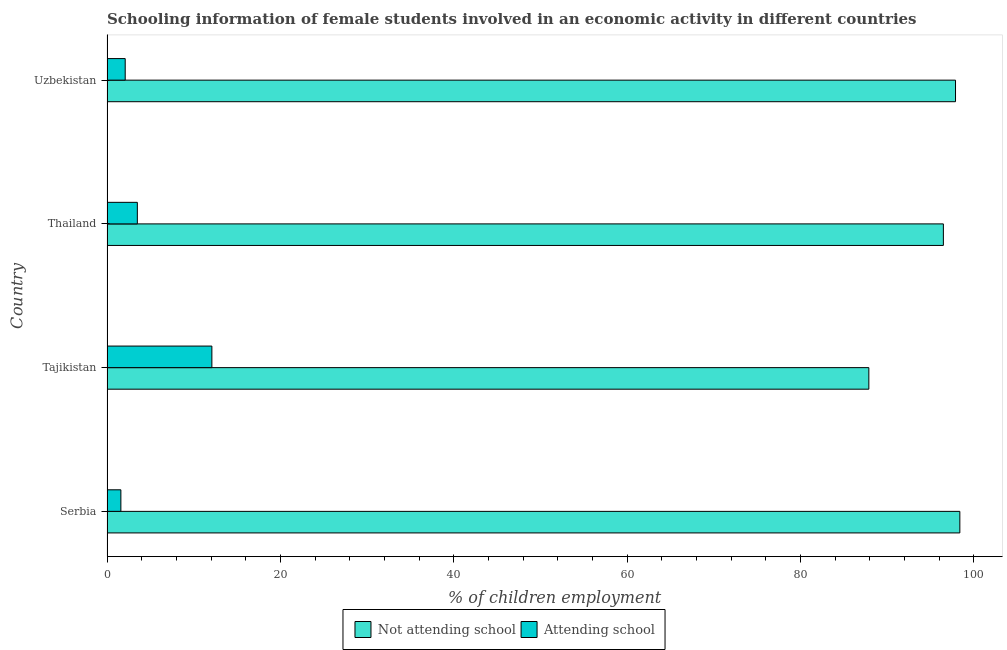How many groups of bars are there?
Give a very brief answer. 4. Are the number of bars on each tick of the Y-axis equal?
Offer a very short reply. Yes. How many bars are there on the 1st tick from the top?
Keep it short and to the point. 2. How many bars are there on the 3rd tick from the bottom?
Give a very brief answer. 2. What is the label of the 3rd group of bars from the top?
Provide a short and direct response. Tajikistan. In which country was the percentage of employed females who are not attending school maximum?
Provide a short and direct response. Serbia. In which country was the percentage of employed females who are not attending school minimum?
Provide a succinct answer. Tajikistan. What is the total percentage of employed females who are attending school in the graph?
Your response must be concise. 19.3. What is the difference between the percentage of employed females who are not attending school in Serbia and that in Uzbekistan?
Ensure brevity in your answer.  0.5. What is the difference between the percentage of employed females who are attending school in Uzbekistan and the percentage of employed females who are not attending school in Tajikistan?
Provide a short and direct response. -85.8. What is the average percentage of employed females who are not attending school per country?
Offer a very short reply. 95.17. What is the difference between the percentage of employed females who are not attending school and percentage of employed females who are attending school in Uzbekistan?
Offer a terse response. 95.8. What is the ratio of the percentage of employed females who are not attending school in Tajikistan to that in Uzbekistan?
Offer a terse response. 0.9. What is the difference between the highest and the second highest percentage of employed females who are attending school?
Keep it short and to the point. 8.6. Is the sum of the percentage of employed females who are not attending school in Serbia and Thailand greater than the maximum percentage of employed females who are attending school across all countries?
Provide a short and direct response. Yes. What does the 1st bar from the top in Uzbekistan represents?
Give a very brief answer. Attending school. What does the 2nd bar from the bottom in Thailand represents?
Your answer should be compact. Attending school. Are all the bars in the graph horizontal?
Ensure brevity in your answer.  Yes. Does the graph contain any zero values?
Offer a very short reply. No. Does the graph contain grids?
Offer a terse response. No. Where does the legend appear in the graph?
Your response must be concise. Bottom center. How many legend labels are there?
Offer a terse response. 2. What is the title of the graph?
Ensure brevity in your answer.  Schooling information of female students involved in an economic activity in different countries. What is the label or title of the X-axis?
Provide a succinct answer. % of children employment. What is the % of children employment of Not attending school in Serbia?
Provide a succinct answer. 98.4. What is the % of children employment of Not attending school in Tajikistan?
Make the answer very short. 87.9. What is the % of children employment in Attending school in Tajikistan?
Offer a terse response. 12.1. What is the % of children employment of Not attending school in Thailand?
Your answer should be compact. 96.5. What is the % of children employment in Attending school in Thailand?
Provide a short and direct response. 3.5. What is the % of children employment of Not attending school in Uzbekistan?
Give a very brief answer. 97.9. Across all countries, what is the maximum % of children employment of Not attending school?
Your answer should be compact. 98.4. Across all countries, what is the minimum % of children employment of Not attending school?
Give a very brief answer. 87.9. What is the total % of children employment of Not attending school in the graph?
Provide a short and direct response. 380.7. What is the total % of children employment of Attending school in the graph?
Your answer should be compact. 19.3. What is the difference between the % of children employment in Not attending school in Serbia and that in Tajikistan?
Make the answer very short. 10.5. What is the difference between the % of children employment of Attending school in Serbia and that in Thailand?
Your answer should be very brief. -1.9. What is the difference between the % of children employment in Attending school in Serbia and that in Uzbekistan?
Offer a terse response. -0.5. What is the difference between the % of children employment in Not attending school in Tajikistan and that in Thailand?
Your answer should be compact. -8.6. What is the difference between the % of children employment of Attending school in Tajikistan and that in Uzbekistan?
Offer a very short reply. 10. What is the difference between the % of children employment of Not attending school in Thailand and that in Uzbekistan?
Provide a short and direct response. -1.4. What is the difference between the % of children employment of Attending school in Thailand and that in Uzbekistan?
Provide a short and direct response. 1.4. What is the difference between the % of children employment of Not attending school in Serbia and the % of children employment of Attending school in Tajikistan?
Give a very brief answer. 86.3. What is the difference between the % of children employment in Not attending school in Serbia and the % of children employment in Attending school in Thailand?
Provide a succinct answer. 94.9. What is the difference between the % of children employment of Not attending school in Serbia and the % of children employment of Attending school in Uzbekistan?
Keep it short and to the point. 96.3. What is the difference between the % of children employment in Not attending school in Tajikistan and the % of children employment in Attending school in Thailand?
Offer a very short reply. 84.4. What is the difference between the % of children employment of Not attending school in Tajikistan and the % of children employment of Attending school in Uzbekistan?
Provide a succinct answer. 85.8. What is the difference between the % of children employment of Not attending school in Thailand and the % of children employment of Attending school in Uzbekistan?
Your answer should be compact. 94.4. What is the average % of children employment in Not attending school per country?
Keep it short and to the point. 95.17. What is the average % of children employment of Attending school per country?
Offer a terse response. 4.83. What is the difference between the % of children employment of Not attending school and % of children employment of Attending school in Serbia?
Provide a succinct answer. 96.8. What is the difference between the % of children employment in Not attending school and % of children employment in Attending school in Tajikistan?
Give a very brief answer. 75.8. What is the difference between the % of children employment in Not attending school and % of children employment in Attending school in Thailand?
Provide a succinct answer. 93. What is the difference between the % of children employment of Not attending school and % of children employment of Attending school in Uzbekistan?
Provide a succinct answer. 95.8. What is the ratio of the % of children employment of Not attending school in Serbia to that in Tajikistan?
Give a very brief answer. 1.12. What is the ratio of the % of children employment in Attending school in Serbia to that in Tajikistan?
Offer a terse response. 0.13. What is the ratio of the % of children employment of Not attending school in Serbia to that in Thailand?
Your response must be concise. 1.02. What is the ratio of the % of children employment in Attending school in Serbia to that in Thailand?
Give a very brief answer. 0.46. What is the ratio of the % of children employment in Not attending school in Serbia to that in Uzbekistan?
Provide a succinct answer. 1.01. What is the ratio of the % of children employment in Attending school in Serbia to that in Uzbekistan?
Ensure brevity in your answer.  0.76. What is the ratio of the % of children employment in Not attending school in Tajikistan to that in Thailand?
Provide a short and direct response. 0.91. What is the ratio of the % of children employment in Attending school in Tajikistan to that in Thailand?
Your answer should be compact. 3.46. What is the ratio of the % of children employment of Not attending school in Tajikistan to that in Uzbekistan?
Give a very brief answer. 0.9. What is the ratio of the % of children employment in Attending school in Tajikistan to that in Uzbekistan?
Keep it short and to the point. 5.76. What is the ratio of the % of children employment of Not attending school in Thailand to that in Uzbekistan?
Make the answer very short. 0.99. What is the ratio of the % of children employment of Attending school in Thailand to that in Uzbekistan?
Offer a terse response. 1.67. What is the difference between the highest and the second highest % of children employment of Attending school?
Keep it short and to the point. 8.6. 